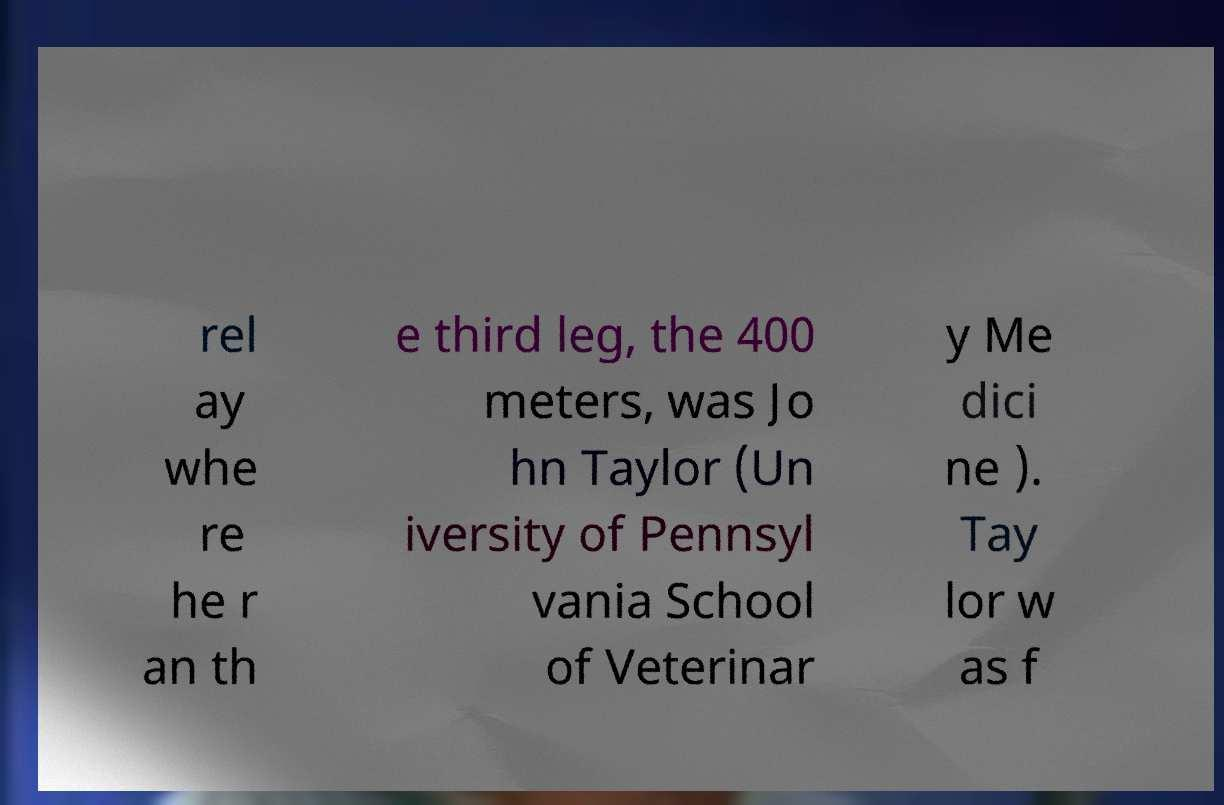Could you extract and type out the text from this image? rel ay whe re he r an th e third leg, the 400 meters, was Jo hn Taylor (Un iversity of Pennsyl vania School of Veterinar y Me dici ne ). Tay lor w as f 